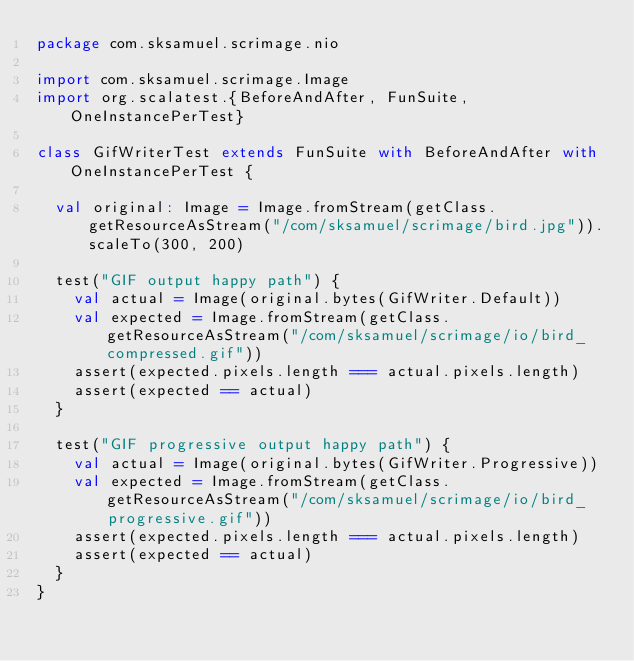Convert code to text. <code><loc_0><loc_0><loc_500><loc_500><_Scala_>package com.sksamuel.scrimage.nio

import com.sksamuel.scrimage.Image
import org.scalatest.{BeforeAndAfter, FunSuite, OneInstancePerTest}

class GifWriterTest extends FunSuite with BeforeAndAfter with OneInstancePerTest {

  val original: Image = Image.fromStream(getClass.getResourceAsStream("/com/sksamuel/scrimage/bird.jpg")).scaleTo(300, 200)

  test("GIF output happy path") {
    val actual = Image(original.bytes(GifWriter.Default))
    val expected = Image.fromStream(getClass.getResourceAsStream("/com/sksamuel/scrimage/io/bird_compressed.gif"))
    assert(expected.pixels.length === actual.pixels.length)
    assert(expected == actual)
  }

  test("GIF progressive output happy path") {
    val actual = Image(original.bytes(GifWriter.Progressive))
    val expected = Image.fromStream(getClass.getResourceAsStream("/com/sksamuel/scrimage/io/bird_progressive.gif"))
    assert(expected.pixels.length === actual.pixels.length)
    assert(expected == actual)
  }
}
</code> 